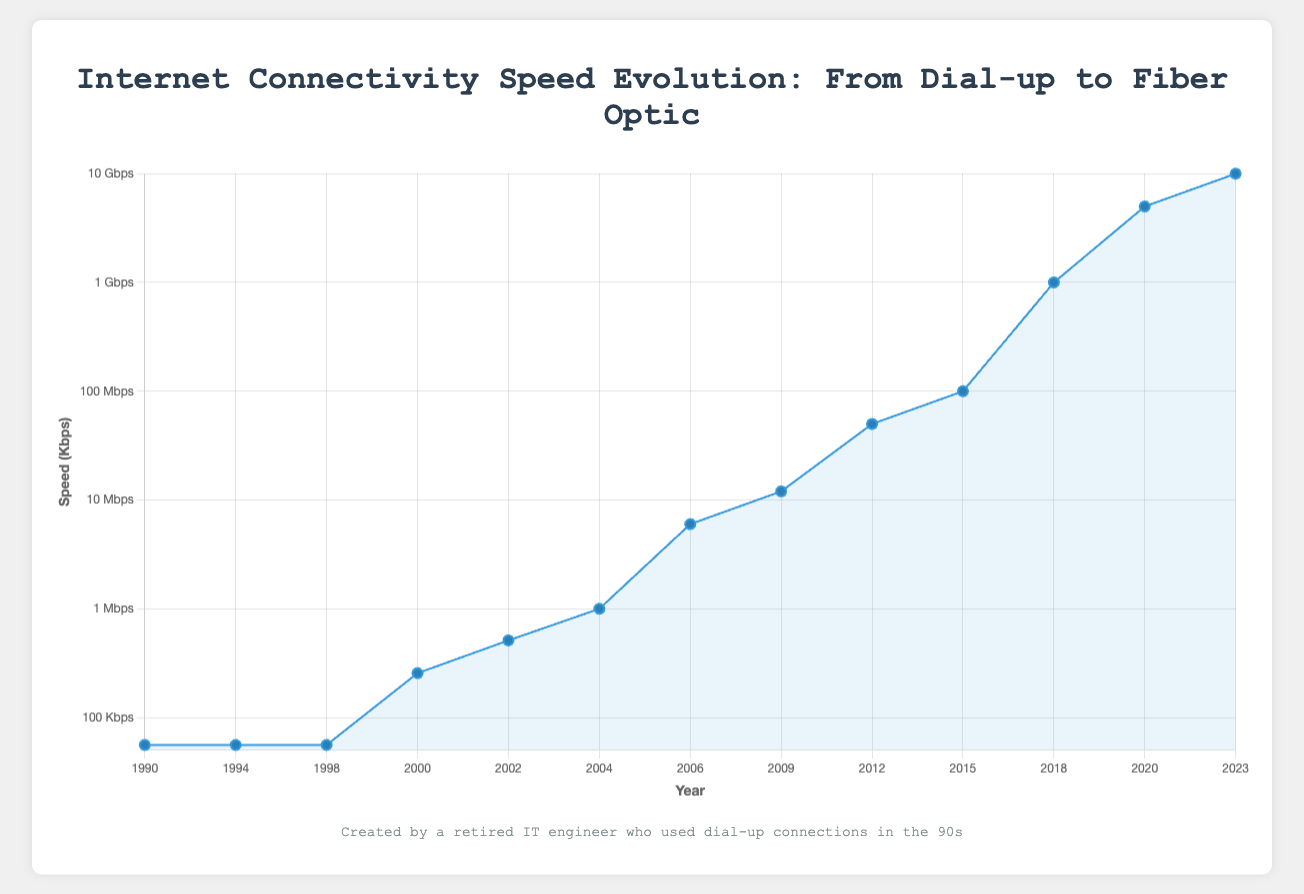How has the maximum speed increased from Dial-up in 1990 to Fiber in 2023? Compare the speed of Dial-up in 1990 (56 Kbps) to the speed of Fiber in 2023 (10,000,000 Kbps). The increase is 10,000,000 Kbps - 56 Kbps = 9,999,944 Kbps.
Answer: 9,999,944 Kbps Which year saw the first introduction of DSL and what was its speed? Look at the year and speed for the first instance of DSL. DSL was first introduced in 2000 with a speed of 256 Kbps.
Answer: 2000, 256 Kbps Between which consecutive years did the speed increase most significantly? Compare the speed increases between each consecutive year. The most significant increase is between 2018 (1,000,000 Kbps) and 2020 (5,000,000 Kbps), with an increase of 4,000,000 Kbps.
Answer: 2018 and 2020 What was the average speed of internet connectivity in the years 2000, 2002, and 2004? Sum the speeds for the years 2000 (256 Kbps), 2002 (512 Kbps), and 2004 (1,000 Kbps), then divide by 3. The average is (256 + 512 + 1,000) / 3 = 589.33 Kbps.
Answer: 589.33 Kbps Which type of internet connectivity had the highest speed and in what year? Identify the highest speed and corresponding type and year from the chart. Fiber in 2023 had the highest speed at 10,000,000 Kbps.
Answer: Fiber, 2023 In which year did cable internet reach speeds of 6 Mbps and which provider example is mentioned? Find the data point for the year, type, and speed for cable internet. In 2006, cable internet reached 6,000 Kbps (6 Mbps) and the provider was Time Warner Cable.
Answer: 2006, Time Warner Cable How many years after the introduction of DSL did Fiber first appear, and what was the speed when it was first introduced? Determine the years and speed for the first instance of DSL (2000) and Fiber (2012). Fiber was introduced 12 years after DSL, with a speed of 50,000 Kbps.
Answer: 12 years, 50,000 Kbps What is the difference in speed between ADSL in 2009 and Fiber in 2015? Identify the speeds for ADSL in 2009 (12,000 Kbps) and Fiber in 2015 (100,000 Kbps). The difference is 100,000 Kbps - 12,000 Kbps = 88,000 Kbps.
Answer: 88,000 Kbps By what factor did internet speeds increase from Dial-up in 1990 to DSL in 2000? Divide the speed of DSL in 2000 (256 Kbps) by the speed of Dial-up in 1990 (56 Kbps). The factor is 256 / 56 ≈ 4.57.
Answer: 4.57 How does the speed evolution appear visually on the plot, particularly after the introduction of Fiber? Observing the chart, internet speeds increased gradually until the introduction of Fiber, after which there is a dramatic upward curve, indicating rapid speed increase.
Answer: Rapid increase after Fiber introduction 